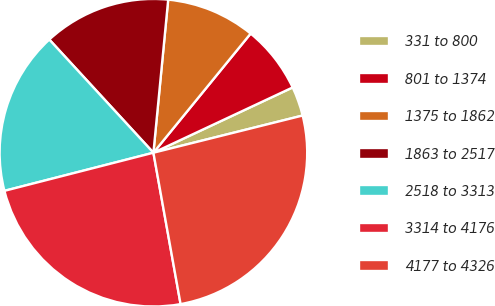Convert chart. <chart><loc_0><loc_0><loc_500><loc_500><pie_chart><fcel>331 to 800<fcel>801 to 1374<fcel>1375 to 1862<fcel>1863 to 2517<fcel>2518 to 3313<fcel>3314 to 4176<fcel>4177 to 4326<nl><fcel>3.09%<fcel>7.13%<fcel>9.36%<fcel>13.37%<fcel>17.15%<fcel>23.84%<fcel>26.06%<nl></chart> 